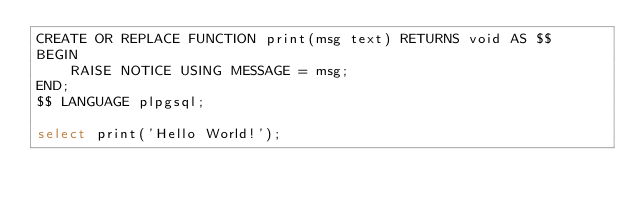<code> <loc_0><loc_0><loc_500><loc_500><_SQL_>CREATE OR REPLACE FUNCTION print(msg text) RETURNS void AS $$
BEGIN
    RAISE NOTICE USING MESSAGE = msg;
END;
$$ LANGUAGE plpgsql;

select print('Hello World!');</code> 